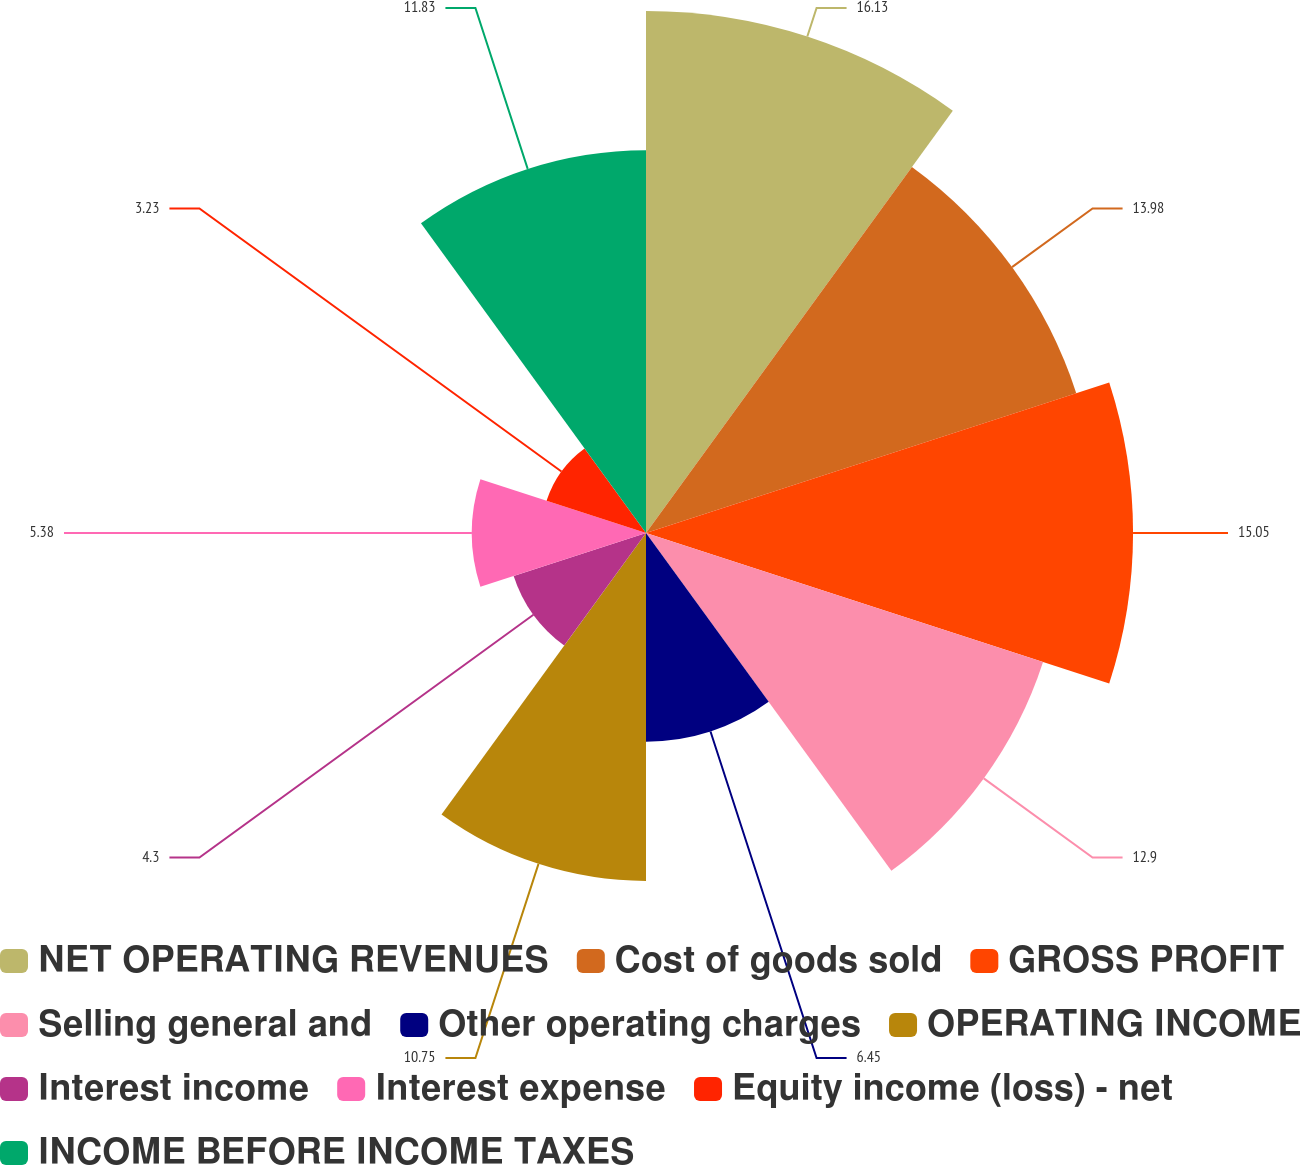Convert chart. <chart><loc_0><loc_0><loc_500><loc_500><pie_chart><fcel>NET OPERATING REVENUES<fcel>Cost of goods sold<fcel>GROSS PROFIT<fcel>Selling general and<fcel>Other operating charges<fcel>OPERATING INCOME<fcel>Interest income<fcel>Interest expense<fcel>Equity income (loss) - net<fcel>INCOME BEFORE INCOME TAXES<nl><fcel>16.13%<fcel>13.98%<fcel>15.05%<fcel>12.9%<fcel>6.45%<fcel>10.75%<fcel>4.3%<fcel>5.38%<fcel>3.23%<fcel>11.83%<nl></chart> 